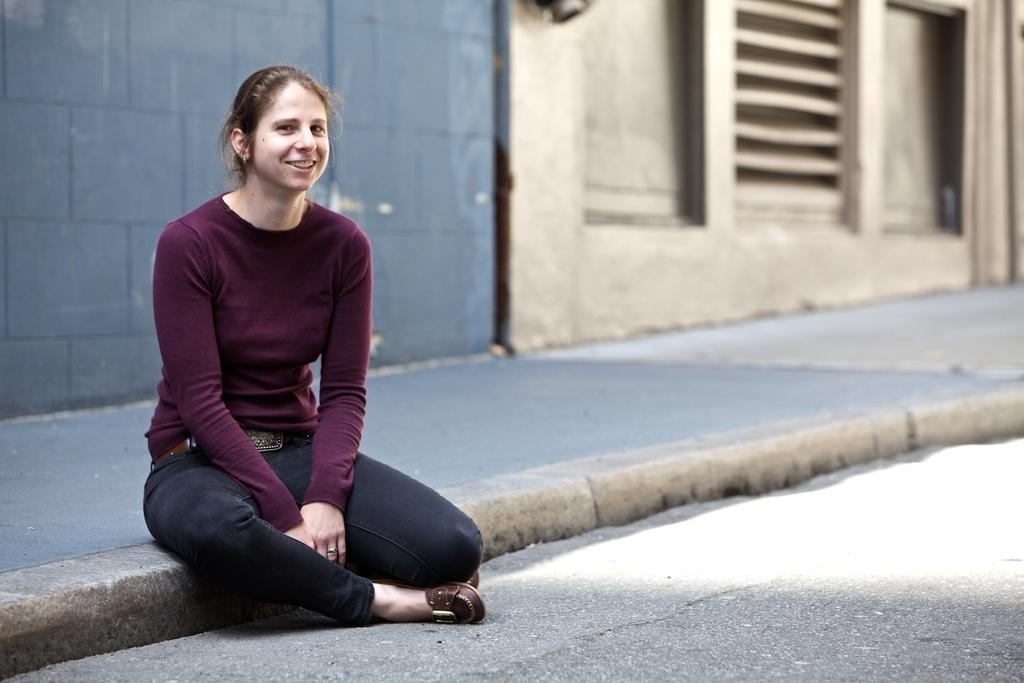Who is the main subject in the image? There is a girl in the image. What is the girl doing in the image? The girl is smiling in the image. Where is the girl sitting in the image? The girl is sitting on the road surface in the image. What can be seen behind the girl in the image? There is a wall behind the girl in the image. What type of silk fabric is draped over the pig in the image? There is no pig or silk fabric present in the image. 